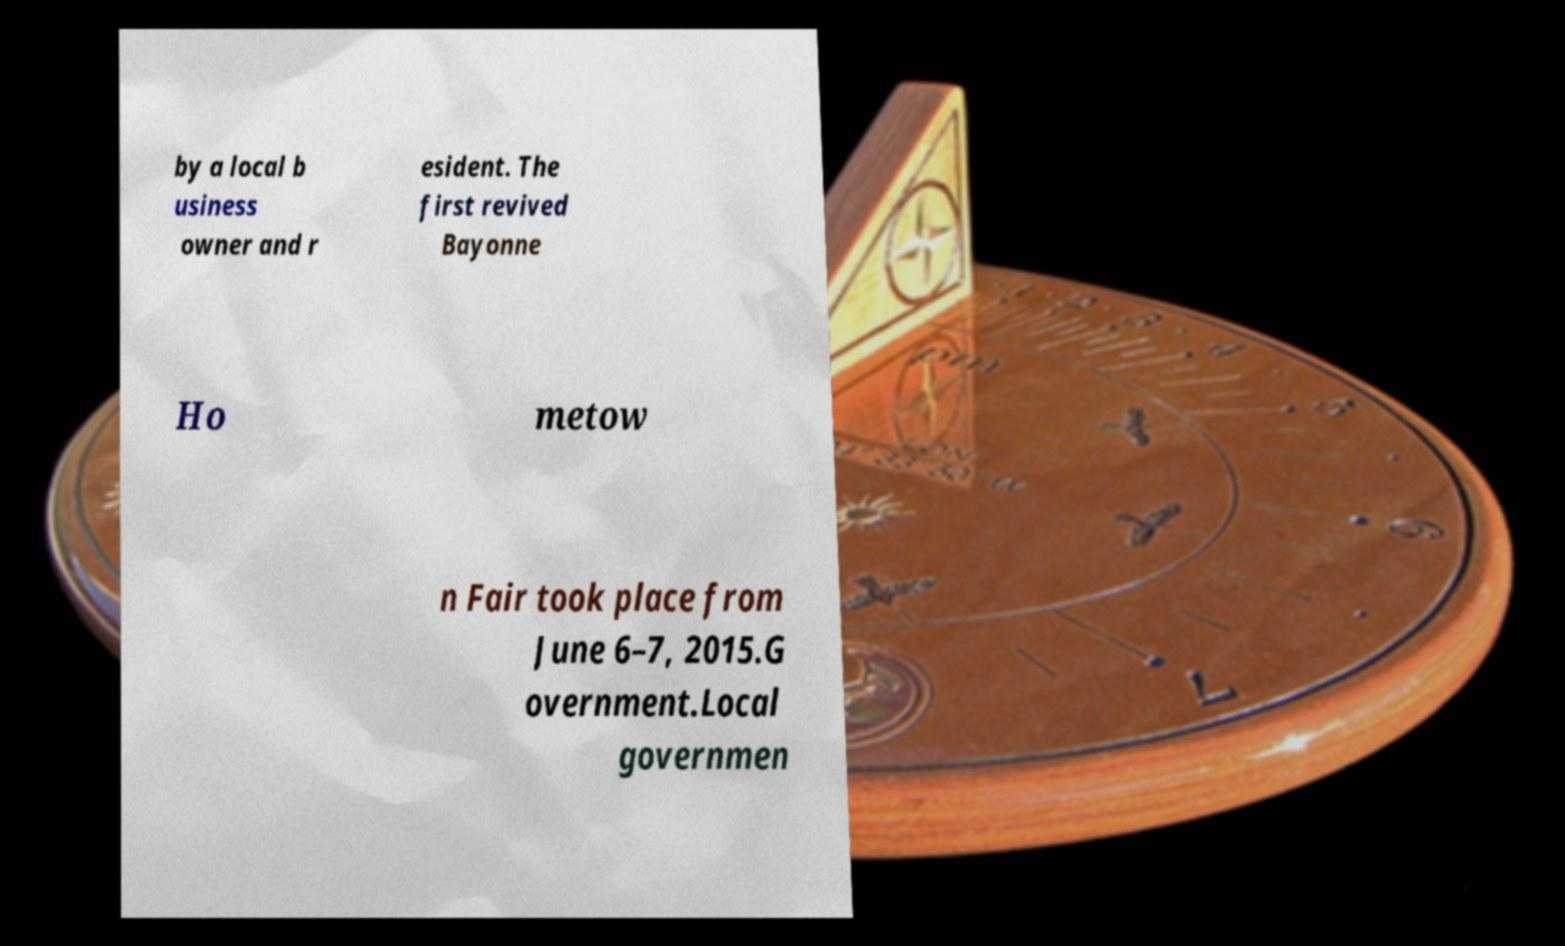For documentation purposes, I need the text within this image transcribed. Could you provide that? by a local b usiness owner and r esident. The first revived Bayonne Ho metow n Fair took place from June 6–7, 2015.G overnment.Local governmen 